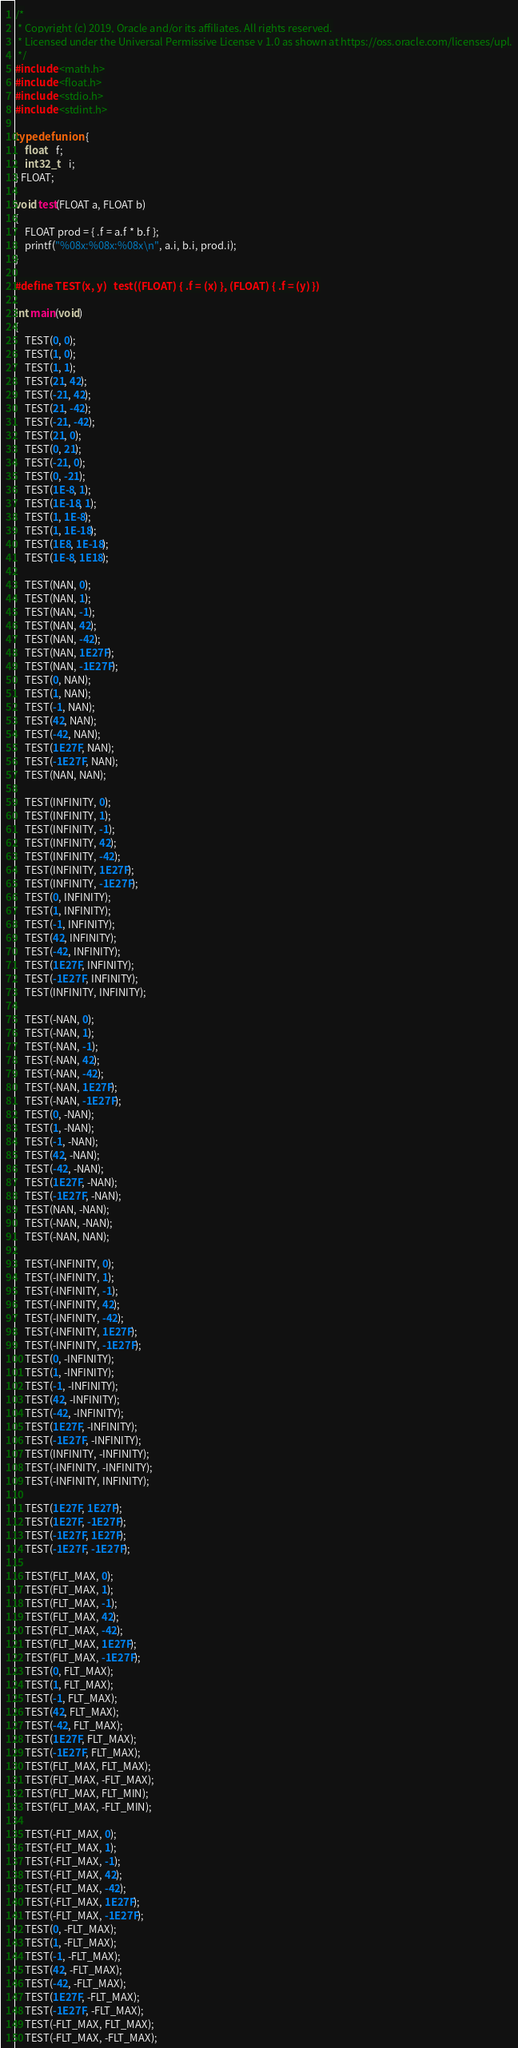<code> <loc_0><loc_0><loc_500><loc_500><_C_>/*
 * Copyright (c) 2019, Oracle and/or its affiliates. All rights reserved.
 * Licensed under the Universal Permissive License v 1.0 as shown at https://oss.oracle.com/licenses/upl.
 */
#include <math.h>
#include <float.h>
#include <stdio.h>
#include <stdint.h>

typedef union {
	float	f;
	int32_t	i;
} FLOAT;

void test(FLOAT a, FLOAT b)
{
	FLOAT prod = { .f = a.f * b.f };
	printf("%08x:%08x:%08x\n", a.i, b.i, prod.i);
}

#define TEST(x, y)	test((FLOAT) { .f = (x) }, (FLOAT) { .f = (y) })

int main(void)
{
	TEST(0, 0);
	TEST(1, 0);
	TEST(1, 1);
	TEST(21, 42);
	TEST(-21, 42);
	TEST(21, -42);
	TEST(-21, -42);
	TEST(21, 0);
	TEST(0, 21);
	TEST(-21, 0);
	TEST(0, -21);
	TEST(1E-8, 1);
	TEST(1E-18, 1);
	TEST(1, 1E-8);
	TEST(1, 1E-18);
	TEST(1E8, 1E-18);
	TEST(1E-8, 1E18);

	TEST(NAN, 0);
	TEST(NAN, 1);
	TEST(NAN, -1);
	TEST(NAN, 42);
	TEST(NAN, -42);
	TEST(NAN, 1E27F);
	TEST(NAN, -1E27F);
	TEST(0, NAN);
	TEST(1, NAN);
	TEST(-1, NAN);
	TEST(42, NAN);
	TEST(-42, NAN);
	TEST(1E27F, NAN);
	TEST(-1E27F, NAN);
	TEST(NAN, NAN);

	TEST(INFINITY, 0);
	TEST(INFINITY, 1);
	TEST(INFINITY, -1);
	TEST(INFINITY, 42);
	TEST(INFINITY, -42);
	TEST(INFINITY, 1E27F);
	TEST(INFINITY, -1E27F);
	TEST(0, INFINITY);
	TEST(1, INFINITY);
	TEST(-1, INFINITY);
	TEST(42, INFINITY);
	TEST(-42, INFINITY);
	TEST(1E27F, INFINITY);
	TEST(-1E27F, INFINITY);
	TEST(INFINITY, INFINITY);

	TEST(-NAN, 0);
	TEST(-NAN, 1);
	TEST(-NAN, -1);
	TEST(-NAN, 42);
	TEST(-NAN, -42);
	TEST(-NAN, 1E27F);
	TEST(-NAN, -1E27F);
	TEST(0, -NAN);
	TEST(1, -NAN);
	TEST(-1, -NAN);
	TEST(42, -NAN);
	TEST(-42, -NAN);
	TEST(1E27F, -NAN);
	TEST(-1E27F, -NAN);
	TEST(NAN, -NAN);
	TEST(-NAN, -NAN);
	TEST(-NAN, NAN);

	TEST(-INFINITY, 0);
	TEST(-INFINITY, 1);
	TEST(-INFINITY, -1);
	TEST(-INFINITY, 42);
	TEST(-INFINITY, -42);
	TEST(-INFINITY, 1E27F);
	TEST(-INFINITY, -1E27F);
	TEST(0, -INFINITY);
	TEST(1, -INFINITY);
	TEST(-1, -INFINITY);
	TEST(42, -INFINITY);
	TEST(-42, -INFINITY);
	TEST(1E27F, -INFINITY);
	TEST(-1E27F, -INFINITY);
	TEST(INFINITY, -INFINITY);
	TEST(-INFINITY, -INFINITY);
	TEST(-INFINITY, INFINITY);

	TEST(1E27F, 1E27F);
	TEST(1E27F, -1E27F);
	TEST(-1E27F, 1E27F);
	TEST(-1E27F, -1E27F);

	TEST(FLT_MAX, 0);
	TEST(FLT_MAX, 1);
	TEST(FLT_MAX, -1);
	TEST(FLT_MAX, 42);
	TEST(FLT_MAX, -42);
	TEST(FLT_MAX, 1E27F);
	TEST(FLT_MAX, -1E27F);
	TEST(0, FLT_MAX);
	TEST(1, FLT_MAX);
	TEST(-1, FLT_MAX);
	TEST(42, FLT_MAX);
	TEST(-42, FLT_MAX);
	TEST(1E27F, FLT_MAX);
	TEST(-1E27F, FLT_MAX);
	TEST(FLT_MAX, FLT_MAX);
	TEST(FLT_MAX, -FLT_MAX);
	TEST(FLT_MAX, FLT_MIN);
	TEST(FLT_MAX, -FLT_MIN);

	TEST(-FLT_MAX, 0);
	TEST(-FLT_MAX, 1);
	TEST(-FLT_MAX, -1);
	TEST(-FLT_MAX, 42);
	TEST(-FLT_MAX, -42);
	TEST(-FLT_MAX, 1E27F);
	TEST(-FLT_MAX, -1E27F);
	TEST(0, -FLT_MAX);
	TEST(1, -FLT_MAX);
	TEST(-1, -FLT_MAX);
	TEST(42, -FLT_MAX);
	TEST(-42, -FLT_MAX);
	TEST(1E27F, -FLT_MAX);
	TEST(-1E27F, -FLT_MAX);
	TEST(-FLT_MAX, FLT_MAX);
	TEST(-FLT_MAX, -FLT_MAX);</code> 